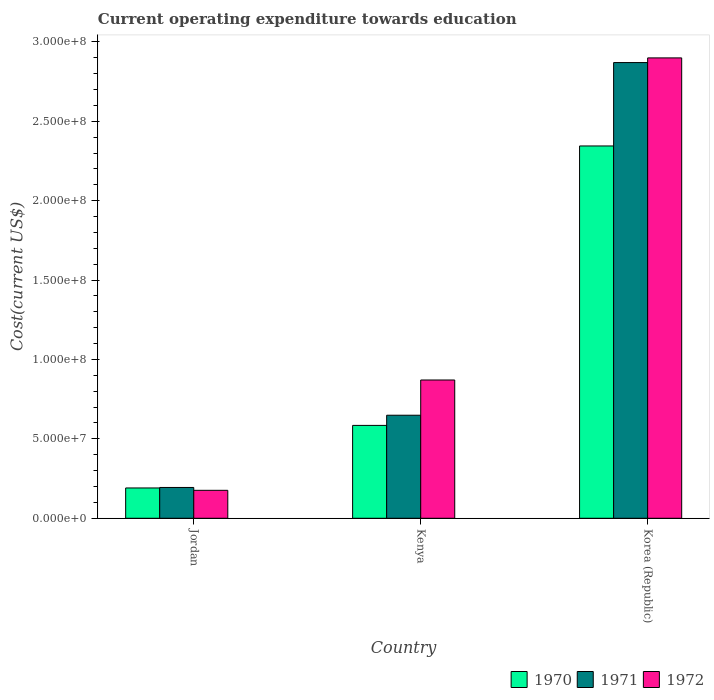How many groups of bars are there?
Provide a short and direct response. 3. Are the number of bars per tick equal to the number of legend labels?
Keep it short and to the point. Yes. Are the number of bars on each tick of the X-axis equal?
Provide a succinct answer. Yes. How many bars are there on the 2nd tick from the left?
Provide a short and direct response. 3. How many bars are there on the 3rd tick from the right?
Make the answer very short. 3. What is the label of the 1st group of bars from the left?
Your answer should be very brief. Jordan. In how many cases, is the number of bars for a given country not equal to the number of legend labels?
Make the answer very short. 0. What is the expenditure towards education in 1972 in Jordan?
Offer a very short reply. 1.76e+07. Across all countries, what is the maximum expenditure towards education in 1972?
Ensure brevity in your answer.  2.90e+08. Across all countries, what is the minimum expenditure towards education in 1972?
Offer a terse response. 1.76e+07. In which country was the expenditure towards education in 1972 maximum?
Offer a terse response. Korea (Republic). In which country was the expenditure towards education in 1971 minimum?
Provide a short and direct response. Jordan. What is the total expenditure towards education in 1970 in the graph?
Give a very brief answer. 3.12e+08. What is the difference between the expenditure towards education in 1972 in Jordan and that in Kenya?
Ensure brevity in your answer.  -6.95e+07. What is the difference between the expenditure towards education in 1972 in Korea (Republic) and the expenditure towards education in 1970 in Kenya?
Provide a short and direct response. 2.31e+08. What is the average expenditure towards education in 1971 per country?
Provide a succinct answer. 1.24e+08. What is the difference between the expenditure towards education of/in 1971 and expenditure towards education of/in 1972 in Korea (Republic)?
Your answer should be compact. -2.95e+06. In how many countries, is the expenditure towards education in 1972 greater than 80000000 US$?
Ensure brevity in your answer.  2. What is the ratio of the expenditure towards education in 1972 in Kenya to that in Korea (Republic)?
Offer a terse response. 0.3. Is the expenditure towards education in 1970 in Jordan less than that in Korea (Republic)?
Your response must be concise. Yes. What is the difference between the highest and the second highest expenditure towards education in 1971?
Provide a short and direct response. 4.55e+07. What is the difference between the highest and the lowest expenditure towards education in 1970?
Your answer should be compact. 2.15e+08. Is the sum of the expenditure towards education in 1970 in Kenya and Korea (Republic) greater than the maximum expenditure towards education in 1971 across all countries?
Make the answer very short. Yes. What does the 2nd bar from the right in Jordan represents?
Offer a terse response. 1971. What is the difference between two consecutive major ticks on the Y-axis?
Give a very brief answer. 5.00e+07. Does the graph contain any zero values?
Provide a short and direct response. No. Does the graph contain grids?
Provide a short and direct response. No. Where does the legend appear in the graph?
Your answer should be very brief. Bottom right. How many legend labels are there?
Ensure brevity in your answer.  3. What is the title of the graph?
Provide a succinct answer. Current operating expenditure towards education. Does "1965" appear as one of the legend labels in the graph?
Your answer should be compact. No. What is the label or title of the X-axis?
Give a very brief answer. Country. What is the label or title of the Y-axis?
Keep it short and to the point. Cost(current US$). What is the Cost(current US$) in 1970 in Jordan?
Your response must be concise. 1.91e+07. What is the Cost(current US$) in 1971 in Jordan?
Your response must be concise. 1.94e+07. What is the Cost(current US$) of 1972 in Jordan?
Keep it short and to the point. 1.76e+07. What is the Cost(current US$) in 1970 in Kenya?
Give a very brief answer. 5.85e+07. What is the Cost(current US$) of 1971 in Kenya?
Offer a very short reply. 6.49e+07. What is the Cost(current US$) in 1972 in Kenya?
Offer a very short reply. 8.71e+07. What is the Cost(current US$) of 1970 in Korea (Republic)?
Your answer should be very brief. 2.34e+08. What is the Cost(current US$) of 1971 in Korea (Republic)?
Provide a short and direct response. 2.87e+08. What is the Cost(current US$) of 1972 in Korea (Republic)?
Your answer should be compact. 2.90e+08. Across all countries, what is the maximum Cost(current US$) in 1970?
Keep it short and to the point. 2.34e+08. Across all countries, what is the maximum Cost(current US$) in 1971?
Ensure brevity in your answer.  2.87e+08. Across all countries, what is the maximum Cost(current US$) in 1972?
Your answer should be very brief. 2.90e+08. Across all countries, what is the minimum Cost(current US$) in 1970?
Offer a very short reply. 1.91e+07. Across all countries, what is the minimum Cost(current US$) of 1971?
Keep it short and to the point. 1.94e+07. Across all countries, what is the minimum Cost(current US$) in 1972?
Provide a short and direct response. 1.76e+07. What is the total Cost(current US$) of 1970 in the graph?
Make the answer very short. 3.12e+08. What is the total Cost(current US$) in 1971 in the graph?
Provide a short and direct response. 3.71e+08. What is the total Cost(current US$) of 1972 in the graph?
Provide a succinct answer. 3.95e+08. What is the difference between the Cost(current US$) in 1970 in Jordan and that in Kenya?
Offer a terse response. -3.94e+07. What is the difference between the Cost(current US$) in 1971 in Jordan and that in Kenya?
Provide a short and direct response. -4.55e+07. What is the difference between the Cost(current US$) of 1972 in Jordan and that in Kenya?
Keep it short and to the point. -6.95e+07. What is the difference between the Cost(current US$) of 1970 in Jordan and that in Korea (Republic)?
Your answer should be compact. -2.15e+08. What is the difference between the Cost(current US$) of 1971 in Jordan and that in Korea (Republic)?
Provide a succinct answer. -2.68e+08. What is the difference between the Cost(current US$) of 1972 in Jordan and that in Korea (Republic)?
Offer a very short reply. -2.72e+08. What is the difference between the Cost(current US$) in 1970 in Kenya and that in Korea (Republic)?
Your answer should be compact. -1.76e+08. What is the difference between the Cost(current US$) in 1971 in Kenya and that in Korea (Republic)?
Give a very brief answer. -2.22e+08. What is the difference between the Cost(current US$) of 1972 in Kenya and that in Korea (Republic)?
Keep it short and to the point. -2.03e+08. What is the difference between the Cost(current US$) of 1970 in Jordan and the Cost(current US$) of 1971 in Kenya?
Ensure brevity in your answer.  -4.58e+07. What is the difference between the Cost(current US$) of 1970 in Jordan and the Cost(current US$) of 1972 in Kenya?
Keep it short and to the point. -6.80e+07. What is the difference between the Cost(current US$) in 1971 in Jordan and the Cost(current US$) in 1972 in Kenya?
Provide a short and direct response. -6.77e+07. What is the difference between the Cost(current US$) in 1970 in Jordan and the Cost(current US$) in 1971 in Korea (Republic)?
Give a very brief answer. -2.68e+08. What is the difference between the Cost(current US$) of 1970 in Jordan and the Cost(current US$) of 1972 in Korea (Republic)?
Provide a short and direct response. -2.71e+08. What is the difference between the Cost(current US$) in 1971 in Jordan and the Cost(current US$) in 1972 in Korea (Republic)?
Your answer should be very brief. -2.71e+08. What is the difference between the Cost(current US$) of 1970 in Kenya and the Cost(current US$) of 1971 in Korea (Republic)?
Your response must be concise. -2.28e+08. What is the difference between the Cost(current US$) of 1970 in Kenya and the Cost(current US$) of 1972 in Korea (Republic)?
Offer a very short reply. -2.31e+08. What is the difference between the Cost(current US$) of 1971 in Kenya and the Cost(current US$) of 1972 in Korea (Republic)?
Offer a very short reply. -2.25e+08. What is the average Cost(current US$) in 1970 per country?
Offer a terse response. 1.04e+08. What is the average Cost(current US$) in 1971 per country?
Offer a very short reply. 1.24e+08. What is the average Cost(current US$) of 1972 per country?
Ensure brevity in your answer.  1.32e+08. What is the difference between the Cost(current US$) of 1970 and Cost(current US$) of 1971 in Jordan?
Make the answer very short. -3.14e+05. What is the difference between the Cost(current US$) in 1970 and Cost(current US$) in 1972 in Jordan?
Your answer should be compact. 1.49e+06. What is the difference between the Cost(current US$) of 1971 and Cost(current US$) of 1972 in Jordan?
Make the answer very short. 1.80e+06. What is the difference between the Cost(current US$) in 1970 and Cost(current US$) in 1971 in Kenya?
Give a very brief answer. -6.41e+06. What is the difference between the Cost(current US$) in 1970 and Cost(current US$) in 1972 in Kenya?
Make the answer very short. -2.86e+07. What is the difference between the Cost(current US$) of 1971 and Cost(current US$) of 1972 in Kenya?
Your answer should be compact. -2.22e+07. What is the difference between the Cost(current US$) of 1970 and Cost(current US$) of 1971 in Korea (Republic)?
Your answer should be compact. -5.25e+07. What is the difference between the Cost(current US$) in 1970 and Cost(current US$) in 1972 in Korea (Republic)?
Your response must be concise. -5.55e+07. What is the difference between the Cost(current US$) in 1971 and Cost(current US$) in 1972 in Korea (Republic)?
Your answer should be very brief. -2.95e+06. What is the ratio of the Cost(current US$) in 1970 in Jordan to that in Kenya?
Your response must be concise. 0.33. What is the ratio of the Cost(current US$) of 1971 in Jordan to that in Kenya?
Provide a short and direct response. 0.3. What is the ratio of the Cost(current US$) in 1972 in Jordan to that in Kenya?
Your response must be concise. 0.2. What is the ratio of the Cost(current US$) in 1970 in Jordan to that in Korea (Republic)?
Ensure brevity in your answer.  0.08. What is the ratio of the Cost(current US$) of 1971 in Jordan to that in Korea (Republic)?
Your answer should be very brief. 0.07. What is the ratio of the Cost(current US$) in 1972 in Jordan to that in Korea (Republic)?
Your response must be concise. 0.06. What is the ratio of the Cost(current US$) in 1970 in Kenya to that in Korea (Republic)?
Offer a terse response. 0.25. What is the ratio of the Cost(current US$) of 1971 in Kenya to that in Korea (Republic)?
Your response must be concise. 0.23. What is the ratio of the Cost(current US$) in 1972 in Kenya to that in Korea (Republic)?
Provide a succinct answer. 0.3. What is the difference between the highest and the second highest Cost(current US$) of 1970?
Your response must be concise. 1.76e+08. What is the difference between the highest and the second highest Cost(current US$) in 1971?
Offer a very short reply. 2.22e+08. What is the difference between the highest and the second highest Cost(current US$) in 1972?
Keep it short and to the point. 2.03e+08. What is the difference between the highest and the lowest Cost(current US$) of 1970?
Keep it short and to the point. 2.15e+08. What is the difference between the highest and the lowest Cost(current US$) of 1971?
Your answer should be very brief. 2.68e+08. What is the difference between the highest and the lowest Cost(current US$) in 1972?
Provide a succinct answer. 2.72e+08. 